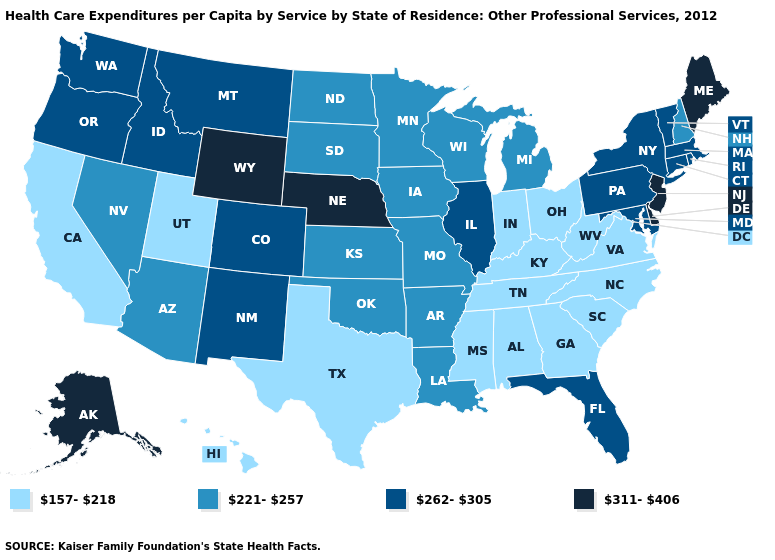Name the states that have a value in the range 262-305?
Write a very short answer. Colorado, Connecticut, Florida, Idaho, Illinois, Maryland, Massachusetts, Montana, New Mexico, New York, Oregon, Pennsylvania, Rhode Island, Vermont, Washington. Name the states that have a value in the range 262-305?
Answer briefly. Colorado, Connecticut, Florida, Idaho, Illinois, Maryland, Massachusetts, Montana, New Mexico, New York, Oregon, Pennsylvania, Rhode Island, Vermont, Washington. What is the lowest value in the USA?
Quick response, please. 157-218. Name the states that have a value in the range 311-406?
Answer briefly. Alaska, Delaware, Maine, Nebraska, New Jersey, Wyoming. What is the lowest value in states that border Ohio?
Give a very brief answer. 157-218. Name the states that have a value in the range 262-305?
Write a very short answer. Colorado, Connecticut, Florida, Idaho, Illinois, Maryland, Massachusetts, Montana, New Mexico, New York, Oregon, Pennsylvania, Rhode Island, Vermont, Washington. Name the states that have a value in the range 221-257?
Quick response, please. Arizona, Arkansas, Iowa, Kansas, Louisiana, Michigan, Minnesota, Missouri, Nevada, New Hampshire, North Dakota, Oklahoma, South Dakota, Wisconsin. What is the value of Mississippi?
Concise answer only. 157-218. What is the highest value in the MidWest ?
Give a very brief answer. 311-406. Name the states that have a value in the range 311-406?
Answer briefly. Alaska, Delaware, Maine, Nebraska, New Jersey, Wyoming. Does the map have missing data?
Short answer required. No. Among the states that border Nebraska , does Colorado have the highest value?
Give a very brief answer. No. Among the states that border New Hampshire , does Maine have the highest value?
Short answer required. Yes. What is the value of North Carolina?
Keep it brief. 157-218. What is the highest value in the USA?
Be succinct. 311-406. 